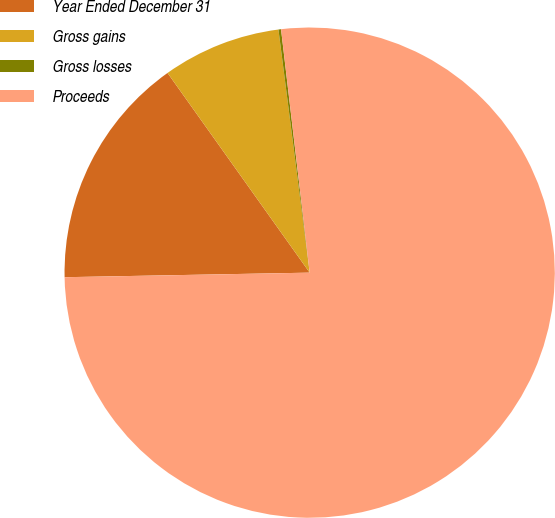Convert chart. <chart><loc_0><loc_0><loc_500><loc_500><pie_chart><fcel>Year Ended December 31<fcel>Gross gains<fcel>Gross losses<fcel>Proceeds<nl><fcel>15.45%<fcel>7.81%<fcel>0.17%<fcel>76.56%<nl></chart> 